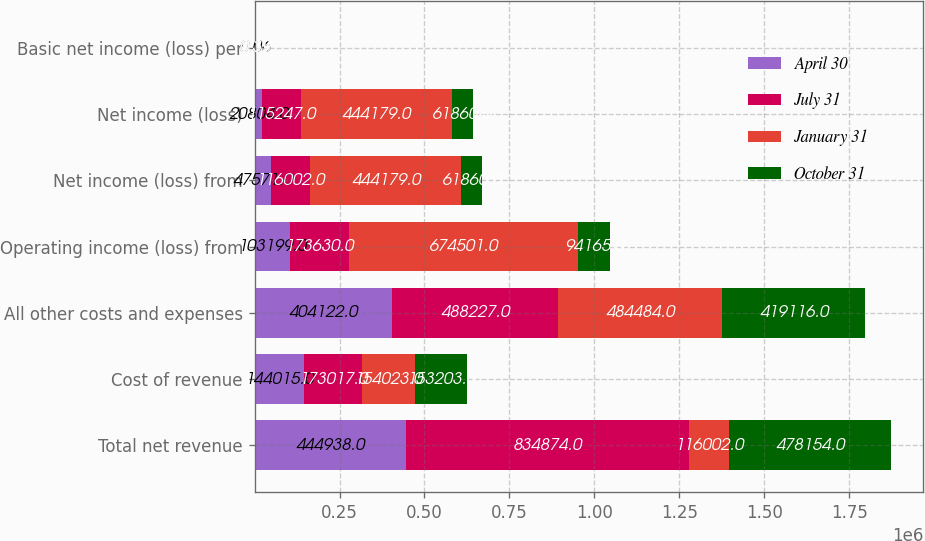Convert chart to OTSL. <chart><loc_0><loc_0><loc_500><loc_500><stacked_bar_chart><ecel><fcel>Total net revenue<fcel>Cost of revenue<fcel>All other costs and expenses<fcel>Operating income (loss) from<fcel>Net income (loss) from<fcel>Net income (loss)<fcel>Basic net income (loss) per<nl><fcel>April 30<fcel>444938<fcel>144015<fcel>404122<fcel>103199<fcel>47571<fcel>20804<fcel>0.06<nl><fcel>July 31<fcel>834874<fcel>173017<fcel>488227<fcel>173630<fcel>116002<fcel>115247<fcel>0.35<nl><fcel>January 31<fcel>116002<fcel>154023<fcel>484484<fcel>674501<fcel>444179<fcel>444179<fcel>1.37<nl><fcel>October 31<fcel>478154<fcel>153203<fcel>419116<fcel>94165<fcel>61860<fcel>61860<fcel>0.19<nl></chart> 